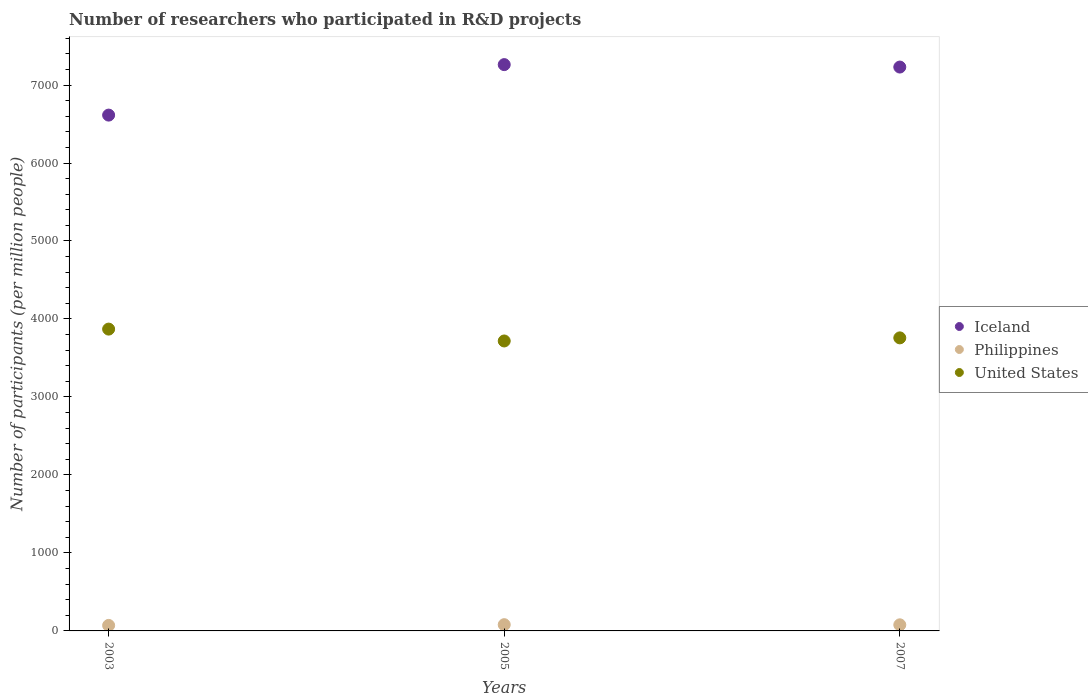How many different coloured dotlines are there?
Your answer should be compact. 3. What is the number of researchers who participated in R&D projects in Iceland in 2003?
Your answer should be very brief. 6614.36. Across all years, what is the maximum number of researchers who participated in R&D projects in Iceland?
Ensure brevity in your answer.  7261.79. Across all years, what is the minimum number of researchers who participated in R&D projects in Iceland?
Provide a short and direct response. 6614.36. In which year was the number of researchers who participated in R&D projects in Iceland maximum?
Your response must be concise. 2005. What is the total number of researchers who participated in R&D projects in Philippines in the graph?
Keep it short and to the point. 228.88. What is the difference between the number of researchers who participated in R&D projects in Iceland in 2003 and that in 2007?
Provide a short and direct response. -616.13. What is the difference between the number of researchers who participated in R&D projects in United States in 2003 and the number of researchers who participated in R&D projects in Philippines in 2005?
Your answer should be very brief. 3790.15. What is the average number of researchers who participated in R&D projects in Philippines per year?
Give a very brief answer. 76.29. In the year 2007, what is the difference between the number of researchers who participated in R&D projects in Philippines and number of researchers who participated in R&D projects in Iceland?
Your answer should be very brief. -7152.29. In how many years, is the number of researchers who participated in R&D projects in United States greater than 7000?
Offer a very short reply. 0. What is the ratio of the number of researchers who participated in R&D projects in Philippines in 2005 to that in 2007?
Offer a very short reply. 1.02. Is the number of researchers who participated in R&D projects in Philippines in 2005 less than that in 2007?
Your response must be concise. No. Is the difference between the number of researchers who participated in R&D projects in Philippines in 2003 and 2005 greater than the difference between the number of researchers who participated in R&D projects in Iceland in 2003 and 2005?
Your answer should be very brief. Yes. What is the difference between the highest and the second highest number of researchers who participated in R&D projects in Iceland?
Your response must be concise. 31.3. What is the difference between the highest and the lowest number of researchers who participated in R&D projects in United States?
Offer a very short reply. 152.16. In how many years, is the number of researchers who participated in R&D projects in Iceland greater than the average number of researchers who participated in R&D projects in Iceland taken over all years?
Offer a very short reply. 2. Is the sum of the number of researchers who participated in R&D projects in Iceland in 2005 and 2007 greater than the maximum number of researchers who participated in R&D projects in United States across all years?
Make the answer very short. Yes. Does the number of researchers who participated in R&D projects in United States monotonically increase over the years?
Your answer should be compact. No. How many dotlines are there?
Provide a succinct answer. 3. How many years are there in the graph?
Give a very brief answer. 3. What is the difference between two consecutive major ticks on the Y-axis?
Offer a terse response. 1000. Are the values on the major ticks of Y-axis written in scientific E-notation?
Provide a short and direct response. No. Does the graph contain any zero values?
Your answer should be compact. No. Does the graph contain grids?
Provide a succinct answer. No. What is the title of the graph?
Give a very brief answer. Number of researchers who participated in R&D projects. What is the label or title of the X-axis?
Your response must be concise. Years. What is the label or title of the Y-axis?
Your answer should be very brief. Number of participants (per million people). What is the Number of participants (per million people) of Iceland in 2003?
Your response must be concise. 6614.36. What is the Number of participants (per million people) in Philippines in 2003?
Offer a very short reply. 70.63. What is the Number of participants (per million people) of United States in 2003?
Ensure brevity in your answer.  3870.21. What is the Number of participants (per million people) in Iceland in 2005?
Your answer should be very brief. 7261.79. What is the Number of participants (per million people) of Philippines in 2005?
Provide a short and direct response. 80.05. What is the Number of participants (per million people) in United States in 2005?
Keep it short and to the point. 3718.05. What is the Number of participants (per million people) of Iceland in 2007?
Ensure brevity in your answer.  7230.49. What is the Number of participants (per million people) in Philippines in 2007?
Keep it short and to the point. 78.2. What is the Number of participants (per million people) in United States in 2007?
Your response must be concise. 3757.78. Across all years, what is the maximum Number of participants (per million people) of Iceland?
Give a very brief answer. 7261.79. Across all years, what is the maximum Number of participants (per million people) of Philippines?
Your answer should be very brief. 80.05. Across all years, what is the maximum Number of participants (per million people) of United States?
Ensure brevity in your answer.  3870.21. Across all years, what is the minimum Number of participants (per million people) in Iceland?
Offer a very short reply. 6614.36. Across all years, what is the minimum Number of participants (per million people) in Philippines?
Make the answer very short. 70.63. Across all years, what is the minimum Number of participants (per million people) of United States?
Make the answer very short. 3718.05. What is the total Number of participants (per million people) in Iceland in the graph?
Offer a terse response. 2.11e+04. What is the total Number of participants (per million people) in Philippines in the graph?
Make the answer very short. 228.88. What is the total Number of participants (per million people) of United States in the graph?
Provide a short and direct response. 1.13e+04. What is the difference between the Number of participants (per million people) of Iceland in 2003 and that in 2005?
Make the answer very short. -647.43. What is the difference between the Number of participants (per million people) of Philippines in 2003 and that in 2005?
Offer a very short reply. -9.43. What is the difference between the Number of participants (per million people) of United States in 2003 and that in 2005?
Provide a succinct answer. 152.16. What is the difference between the Number of participants (per million people) of Iceland in 2003 and that in 2007?
Provide a succinct answer. -616.13. What is the difference between the Number of participants (per million people) of Philippines in 2003 and that in 2007?
Offer a very short reply. -7.57. What is the difference between the Number of participants (per million people) of United States in 2003 and that in 2007?
Keep it short and to the point. 112.42. What is the difference between the Number of participants (per million people) in Iceland in 2005 and that in 2007?
Ensure brevity in your answer.  31.3. What is the difference between the Number of participants (per million people) in Philippines in 2005 and that in 2007?
Provide a short and direct response. 1.86. What is the difference between the Number of participants (per million people) in United States in 2005 and that in 2007?
Your answer should be very brief. -39.73. What is the difference between the Number of participants (per million people) of Iceland in 2003 and the Number of participants (per million people) of Philippines in 2005?
Your answer should be very brief. 6534.3. What is the difference between the Number of participants (per million people) in Iceland in 2003 and the Number of participants (per million people) in United States in 2005?
Offer a terse response. 2896.31. What is the difference between the Number of participants (per million people) in Philippines in 2003 and the Number of participants (per million people) in United States in 2005?
Your response must be concise. -3647.42. What is the difference between the Number of participants (per million people) in Iceland in 2003 and the Number of participants (per million people) in Philippines in 2007?
Your response must be concise. 6536.16. What is the difference between the Number of participants (per million people) of Iceland in 2003 and the Number of participants (per million people) of United States in 2007?
Provide a succinct answer. 2856.58. What is the difference between the Number of participants (per million people) of Philippines in 2003 and the Number of participants (per million people) of United States in 2007?
Ensure brevity in your answer.  -3687.16. What is the difference between the Number of participants (per million people) of Iceland in 2005 and the Number of participants (per million people) of Philippines in 2007?
Offer a very short reply. 7183.59. What is the difference between the Number of participants (per million people) in Iceland in 2005 and the Number of participants (per million people) in United States in 2007?
Provide a short and direct response. 3504.01. What is the difference between the Number of participants (per million people) in Philippines in 2005 and the Number of participants (per million people) in United States in 2007?
Make the answer very short. -3677.73. What is the average Number of participants (per million people) of Iceland per year?
Offer a very short reply. 7035.55. What is the average Number of participants (per million people) in Philippines per year?
Make the answer very short. 76.29. What is the average Number of participants (per million people) of United States per year?
Your answer should be compact. 3782.01. In the year 2003, what is the difference between the Number of participants (per million people) of Iceland and Number of participants (per million people) of Philippines?
Your answer should be compact. 6543.73. In the year 2003, what is the difference between the Number of participants (per million people) of Iceland and Number of participants (per million people) of United States?
Your response must be concise. 2744.15. In the year 2003, what is the difference between the Number of participants (per million people) of Philippines and Number of participants (per million people) of United States?
Provide a succinct answer. -3799.58. In the year 2005, what is the difference between the Number of participants (per million people) in Iceland and Number of participants (per million people) in Philippines?
Keep it short and to the point. 7181.74. In the year 2005, what is the difference between the Number of participants (per million people) of Iceland and Number of participants (per million people) of United States?
Provide a short and direct response. 3543.74. In the year 2005, what is the difference between the Number of participants (per million people) of Philippines and Number of participants (per million people) of United States?
Keep it short and to the point. -3637.99. In the year 2007, what is the difference between the Number of participants (per million people) of Iceland and Number of participants (per million people) of Philippines?
Provide a short and direct response. 7152.29. In the year 2007, what is the difference between the Number of participants (per million people) of Iceland and Number of participants (per million people) of United States?
Give a very brief answer. 3472.71. In the year 2007, what is the difference between the Number of participants (per million people) in Philippines and Number of participants (per million people) in United States?
Give a very brief answer. -3679.58. What is the ratio of the Number of participants (per million people) of Iceland in 2003 to that in 2005?
Offer a terse response. 0.91. What is the ratio of the Number of participants (per million people) of Philippines in 2003 to that in 2005?
Ensure brevity in your answer.  0.88. What is the ratio of the Number of participants (per million people) of United States in 2003 to that in 2005?
Provide a short and direct response. 1.04. What is the ratio of the Number of participants (per million people) of Iceland in 2003 to that in 2007?
Provide a succinct answer. 0.91. What is the ratio of the Number of participants (per million people) of Philippines in 2003 to that in 2007?
Offer a very short reply. 0.9. What is the ratio of the Number of participants (per million people) in United States in 2003 to that in 2007?
Keep it short and to the point. 1.03. What is the ratio of the Number of participants (per million people) of Philippines in 2005 to that in 2007?
Your response must be concise. 1.02. What is the difference between the highest and the second highest Number of participants (per million people) of Iceland?
Offer a very short reply. 31.3. What is the difference between the highest and the second highest Number of participants (per million people) in Philippines?
Offer a terse response. 1.86. What is the difference between the highest and the second highest Number of participants (per million people) in United States?
Your answer should be compact. 112.42. What is the difference between the highest and the lowest Number of participants (per million people) of Iceland?
Your answer should be very brief. 647.43. What is the difference between the highest and the lowest Number of participants (per million people) of Philippines?
Keep it short and to the point. 9.43. What is the difference between the highest and the lowest Number of participants (per million people) of United States?
Give a very brief answer. 152.16. 